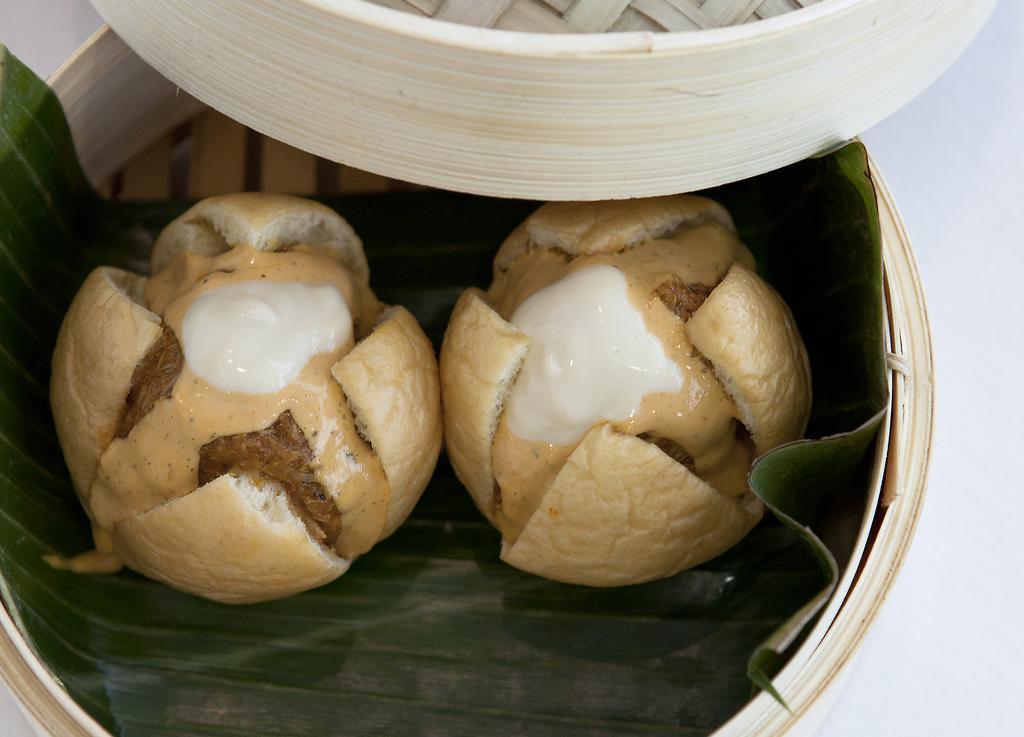In one or two sentences, can you explain what this image depicts? In this image we can see food and banana leaf in container placed on the table. 